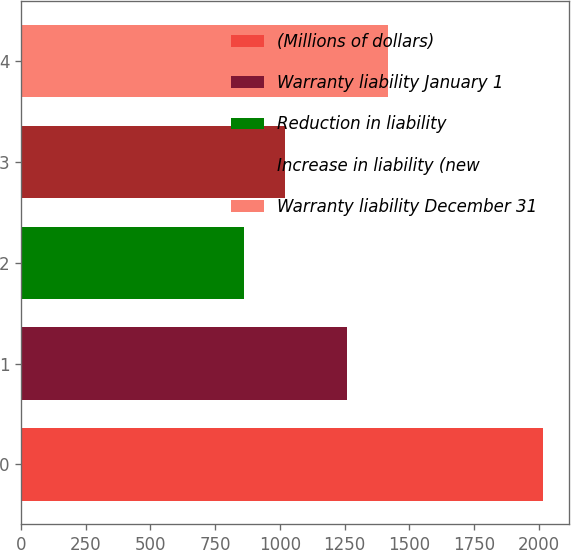Convert chart to OTSL. <chart><loc_0><loc_0><loc_500><loc_500><bar_chart><fcel>(Millions of dollars)<fcel>Warranty liability January 1<fcel>Reduction in liability<fcel>Increase in liability (new<fcel>Warranty liability December 31<nl><fcel>2017<fcel>1258<fcel>860<fcel>1021<fcel>1419<nl></chart> 